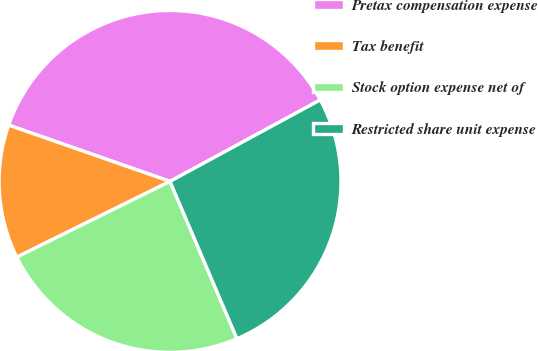<chart> <loc_0><loc_0><loc_500><loc_500><pie_chart><fcel>Pretax compensation expense<fcel>Tax benefit<fcel>Stock option expense net of<fcel>Restricted share unit expense<nl><fcel>36.75%<fcel>12.65%<fcel>24.1%<fcel>26.51%<nl></chart> 